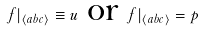Convert formula to latex. <formula><loc_0><loc_0><loc_500><loc_500>f | _ { \langle a b c \rangle } \equiv u \text { or } f | _ { \langle a b c \rangle } = p</formula> 